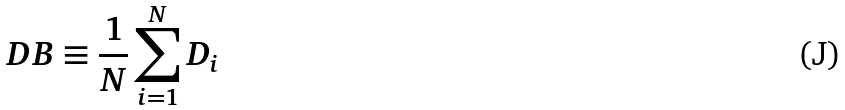Convert formula to latex. <formula><loc_0><loc_0><loc_500><loc_500>D B \equiv \frac { 1 } { N } \sum _ { i = 1 } ^ { N } D _ { i }</formula> 